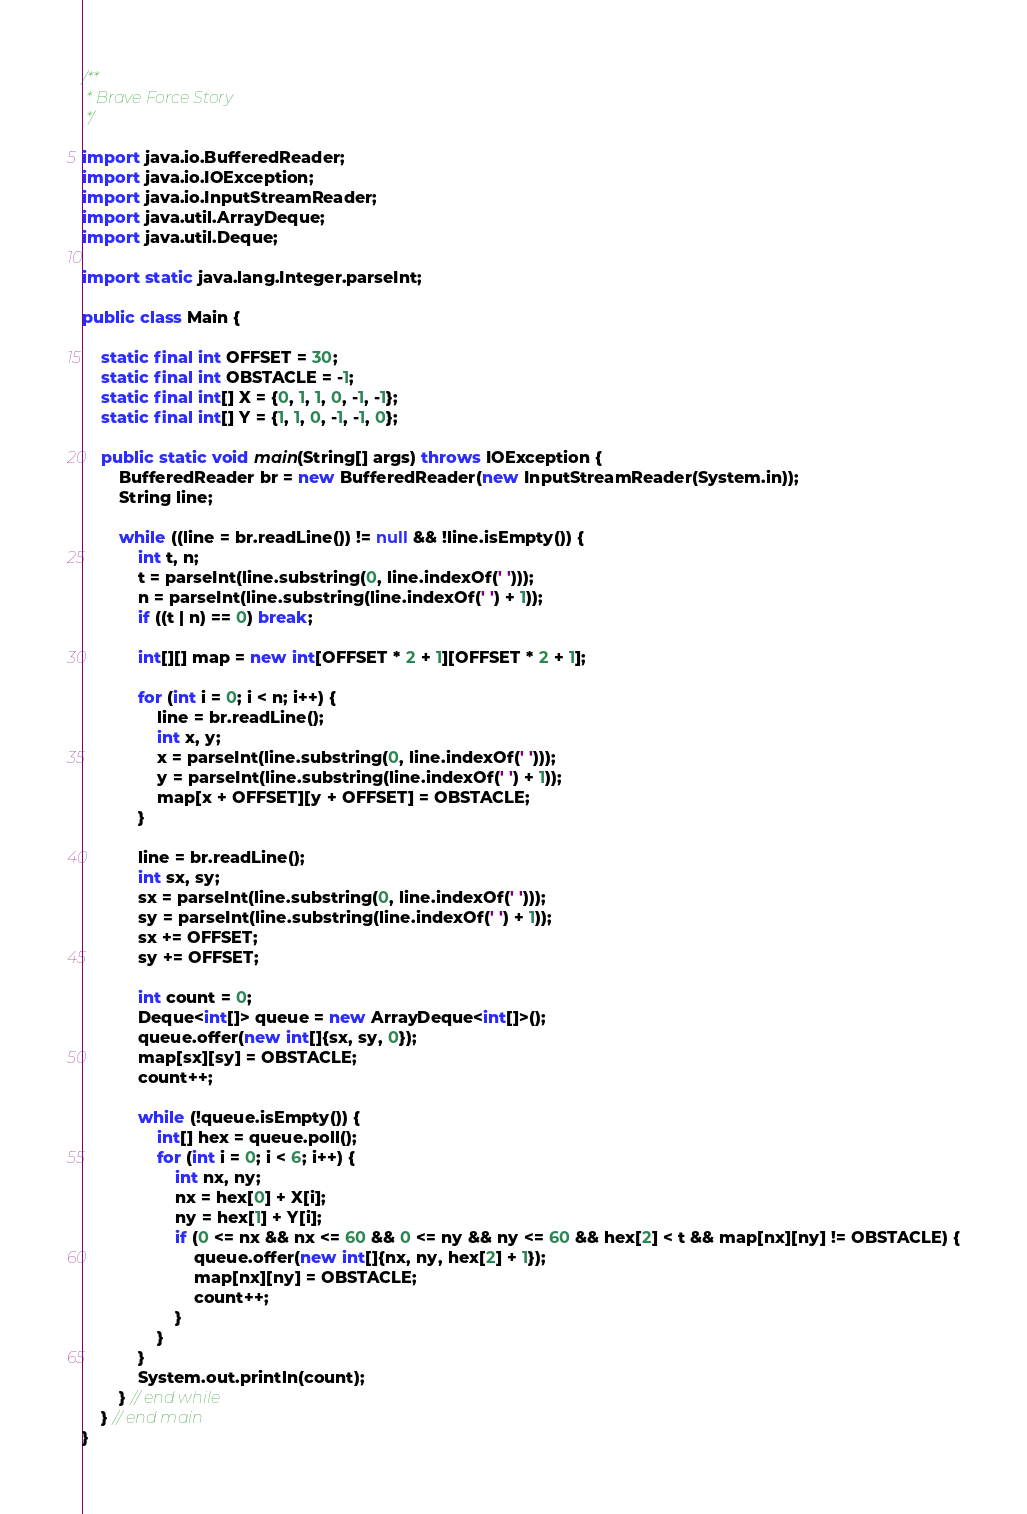Convert code to text. <code><loc_0><loc_0><loc_500><loc_500><_Java_>/**
 * Brave Force Story
 */

import java.io.BufferedReader;
import java.io.IOException;
import java.io.InputStreamReader;
import java.util.ArrayDeque;
import java.util.Deque;

import static java.lang.Integer.parseInt;

public class Main {

	static final int OFFSET = 30;
	static final int OBSTACLE = -1;
	static final int[] X = {0, 1, 1, 0, -1, -1};
	static final int[] Y = {1, 1, 0, -1, -1, 0};

	public static void main(String[] args) throws IOException {
		BufferedReader br = new BufferedReader(new InputStreamReader(System.in));
		String line;

		while ((line = br.readLine()) != null && !line.isEmpty()) {
			int t, n;
			t = parseInt(line.substring(0, line.indexOf(' ')));
			n = parseInt(line.substring(line.indexOf(' ') + 1));
			if ((t | n) == 0) break;

			int[][] map = new int[OFFSET * 2 + 1][OFFSET * 2 + 1];

			for (int i = 0; i < n; i++) {
				line = br.readLine();
				int x, y;
				x = parseInt(line.substring(0, line.indexOf(' ')));
				y = parseInt(line.substring(line.indexOf(' ') + 1));
				map[x + OFFSET][y + OFFSET] = OBSTACLE;
			}

			line = br.readLine();
			int sx, sy;
			sx = parseInt(line.substring(0, line.indexOf(' ')));
			sy = parseInt(line.substring(line.indexOf(' ') + 1));
			sx += OFFSET;
			sy += OFFSET;

			int count = 0;
			Deque<int[]> queue = new ArrayDeque<int[]>();
			queue.offer(new int[]{sx, sy, 0});
			map[sx][sy] = OBSTACLE;
			count++;

			while (!queue.isEmpty()) {
				int[] hex = queue.poll();
				for (int i = 0; i < 6; i++) {
					int nx, ny;
					nx = hex[0] + X[i];
					ny = hex[1] + Y[i];
					if (0 <= nx && nx <= 60 && 0 <= ny && ny <= 60 && hex[2] < t && map[nx][ny] != OBSTACLE) {
						queue.offer(new int[]{nx, ny, hex[2] + 1});
						map[nx][ny] = OBSTACLE;
						count++;
					}
				}
			}
			System.out.println(count);
		} // end while
	} // end main
}</code> 